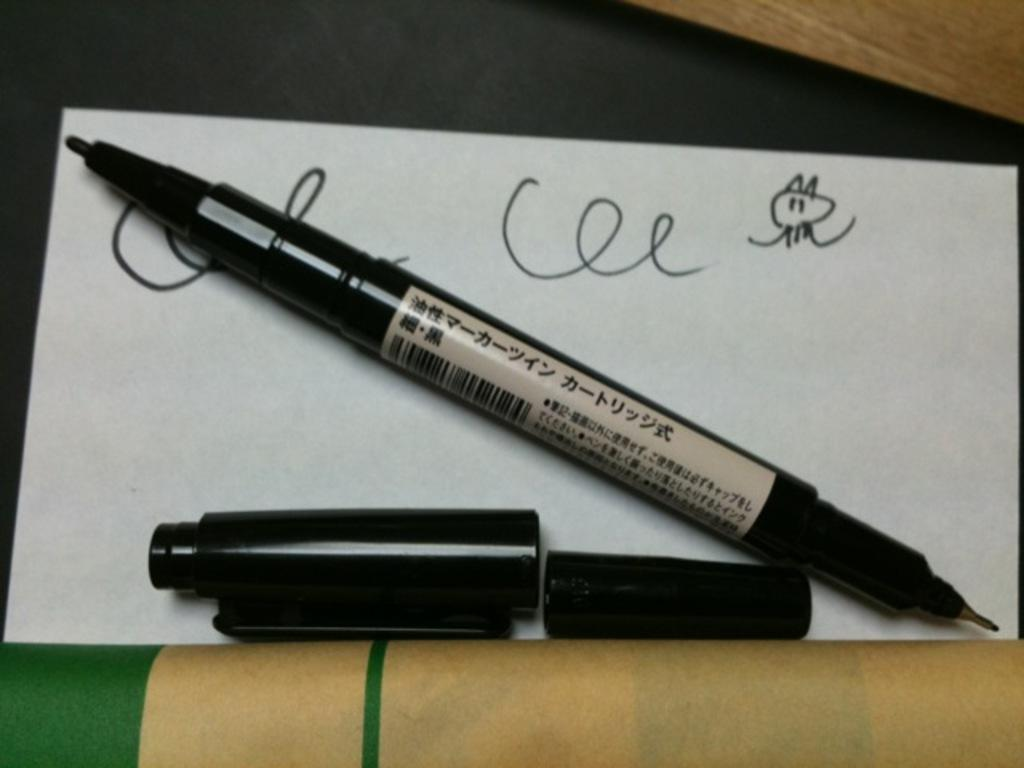What is the main subject in the center of the image? There is a card with a pen in the center of the image. What can be seen on the card? There is text on the card. What type of furniture is visible in the background of the image? There appears to be a table in the background of the image. What is located at the bottom of the image? There is an object at the bottom of the image. What type of stocking is hanging from the card in the image? There is no stocking present in the image; it only features a card with a pen and text. 